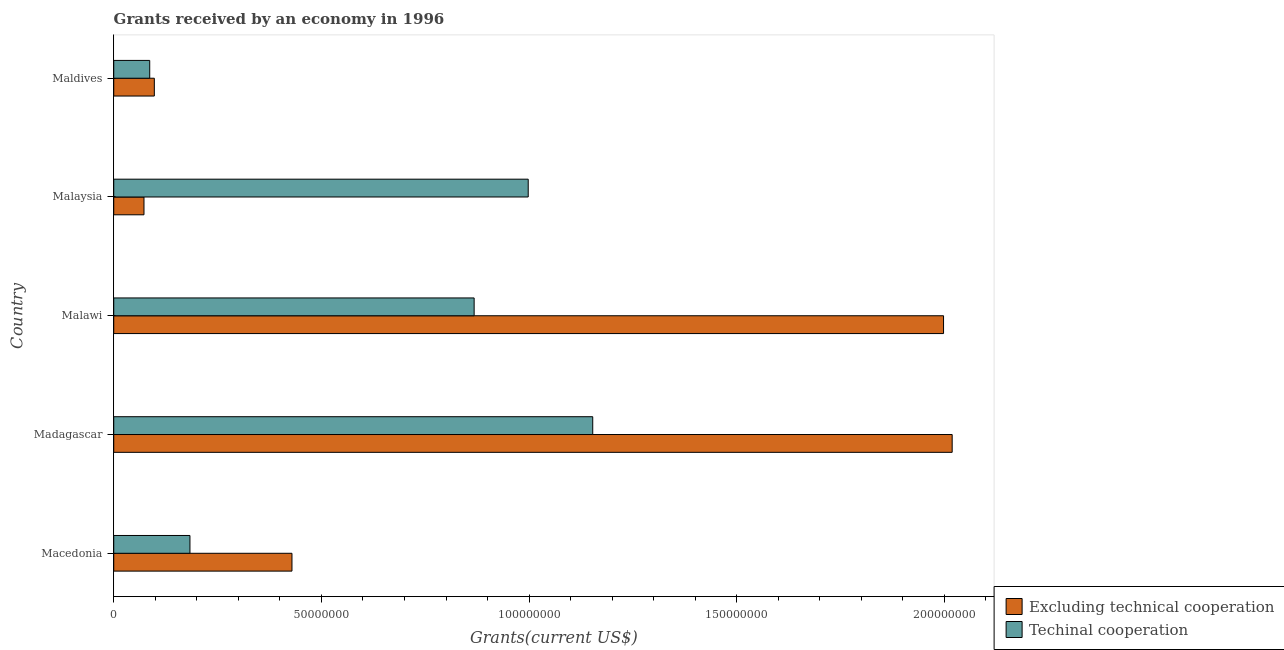How many different coloured bars are there?
Keep it short and to the point. 2. How many groups of bars are there?
Provide a succinct answer. 5. Are the number of bars per tick equal to the number of legend labels?
Ensure brevity in your answer.  Yes. Are the number of bars on each tick of the Y-axis equal?
Provide a succinct answer. Yes. How many bars are there on the 4th tick from the top?
Ensure brevity in your answer.  2. How many bars are there on the 5th tick from the bottom?
Keep it short and to the point. 2. What is the label of the 5th group of bars from the top?
Ensure brevity in your answer.  Macedonia. In how many cases, is the number of bars for a given country not equal to the number of legend labels?
Provide a short and direct response. 0. What is the amount of grants received(including technical cooperation) in Madagascar?
Your answer should be compact. 1.15e+08. Across all countries, what is the maximum amount of grants received(excluding technical cooperation)?
Offer a terse response. 2.02e+08. Across all countries, what is the minimum amount of grants received(including technical cooperation)?
Keep it short and to the point. 8.66e+06. In which country was the amount of grants received(including technical cooperation) maximum?
Offer a very short reply. Madagascar. In which country was the amount of grants received(including technical cooperation) minimum?
Offer a terse response. Maldives. What is the total amount of grants received(including technical cooperation) in the graph?
Keep it short and to the point. 3.29e+08. What is the difference between the amount of grants received(excluding technical cooperation) in Malawi and that in Malaysia?
Your response must be concise. 1.92e+08. What is the difference between the amount of grants received(excluding technical cooperation) in Malaysia and the amount of grants received(including technical cooperation) in Madagascar?
Offer a very short reply. -1.08e+08. What is the average amount of grants received(including technical cooperation) per country?
Your answer should be very brief. 6.58e+07. What is the difference between the amount of grants received(excluding technical cooperation) and amount of grants received(including technical cooperation) in Madagascar?
Make the answer very short. 8.65e+07. What is the ratio of the amount of grants received(excluding technical cooperation) in Madagascar to that in Maldives?
Offer a terse response. 20.66. Is the amount of grants received(including technical cooperation) in Macedonia less than that in Malawi?
Keep it short and to the point. Yes. What is the difference between the highest and the second highest amount of grants received(including technical cooperation)?
Your answer should be compact. 1.55e+07. What is the difference between the highest and the lowest amount of grants received(excluding technical cooperation)?
Offer a terse response. 1.95e+08. What does the 2nd bar from the top in Malaysia represents?
Your response must be concise. Excluding technical cooperation. What does the 1st bar from the bottom in Macedonia represents?
Your answer should be compact. Excluding technical cooperation. How many bars are there?
Offer a terse response. 10. Are all the bars in the graph horizontal?
Offer a very short reply. Yes. What is the difference between two consecutive major ticks on the X-axis?
Offer a terse response. 5.00e+07. Does the graph contain grids?
Give a very brief answer. No. How are the legend labels stacked?
Keep it short and to the point. Vertical. What is the title of the graph?
Ensure brevity in your answer.  Grants received by an economy in 1996. What is the label or title of the X-axis?
Offer a very short reply. Grants(current US$). What is the label or title of the Y-axis?
Ensure brevity in your answer.  Country. What is the Grants(current US$) of Excluding technical cooperation in Macedonia?
Offer a terse response. 4.29e+07. What is the Grants(current US$) of Techinal cooperation in Macedonia?
Your response must be concise. 1.84e+07. What is the Grants(current US$) of Excluding technical cooperation in Madagascar?
Keep it short and to the point. 2.02e+08. What is the Grants(current US$) of Techinal cooperation in Madagascar?
Your answer should be very brief. 1.15e+08. What is the Grants(current US$) of Excluding technical cooperation in Malawi?
Make the answer very short. 2.00e+08. What is the Grants(current US$) in Techinal cooperation in Malawi?
Provide a succinct answer. 8.68e+07. What is the Grants(current US$) in Excluding technical cooperation in Malaysia?
Keep it short and to the point. 7.28e+06. What is the Grants(current US$) in Techinal cooperation in Malaysia?
Offer a very short reply. 9.98e+07. What is the Grants(current US$) of Excluding technical cooperation in Maldives?
Make the answer very short. 9.77e+06. What is the Grants(current US$) of Techinal cooperation in Maldives?
Your answer should be very brief. 8.66e+06. Across all countries, what is the maximum Grants(current US$) in Excluding technical cooperation?
Ensure brevity in your answer.  2.02e+08. Across all countries, what is the maximum Grants(current US$) in Techinal cooperation?
Provide a succinct answer. 1.15e+08. Across all countries, what is the minimum Grants(current US$) in Excluding technical cooperation?
Offer a terse response. 7.28e+06. Across all countries, what is the minimum Grants(current US$) in Techinal cooperation?
Make the answer very short. 8.66e+06. What is the total Grants(current US$) of Excluding technical cooperation in the graph?
Your answer should be compact. 4.62e+08. What is the total Grants(current US$) of Techinal cooperation in the graph?
Your answer should be very brief. 3.29e+08. What is the difference between the Grants(current US$) in Excluding technical cooperation in Macedonia and that in Madagascar?
Give a very brief answer. -1.59e+08. What is the difference between the Grants(current US$) of Techinal cooperation in Macedonia and that in Madagascar?
Your answer should be very brief. -9.70e+07. What is the difference between the Grants(current US$) in Excluding technical cooperation in Macedonia and that in Malawi?
Offer a terse response. -1.57e+08. What is the difference between the Grants(current US$) in Techinal cooperation in Macedonia and that in Malawi?
Offer a terse response. -6.84e+07. What is the difference between the Grants(current US$) in Excluding technical cooperation in Macedonia and that in Malaysia?
Offer a terse response. 3.56e+07. What is the difference between the Grants(current US$) of Techinal cooperation in Macedonia and that in Malaysia?
Offer a terse response. -8.14e+07. What is the difference between the Grants(current US$) in Excluding technical cooperation in Macedonia and that in Maldives?
Give a very brief answer. 3.31e+07. What is the difference between the Grants(current US$) of Techinal cooperation in Macedonia and that in Maldives?
Make the answer very short. 9.69e+06. What is the difference between the Grants(current US$) in Excluding technical cooperation in Madagascar and that in Malawi?
Make the answer very short. 2.08e+06. What is the difference between the Grants(current US$) of Techinal cooperation in Madagascar and that in Malawi?
Offer a very short reply. 2.86e+07. What is the difference between the Grants(current US$) in Excluding technical cooperation in Madagascar and that in Malaysia?
Offer a very short reply. 1.95e+08. What is the difference between the Grants(current US$) in Techinal cooperation in Madagascar and that in Malaysia?
Your response must be concise. 1.55e+07. What is the difference between the Grants(current US$) in Excluding technical cooperation in Madagascar and that in Maldives?
Ensure brevity in your answer.  1.92e+08. What is the difference between the Grants(current US$) of Techinal cooperation in Madagascar and that in Maldives?
Your answer should be very brief. 1.07e+08. What is the difference between the Grants(current US$) in Excluding technical cooperation in Malawi and that in Malaysia?
Keep it short and to the point. 1.92e+08. What is the difference between the Grants(current US$) in Techinal cooperation in Malawi and that in Malaysia?
Offer a terse response. -1.30e+07. What is the difference between the Grants(current US$) in Excluding technical cooperation in Malawi and that in Maldives?
Offer a terse response. 1.90e+08. What is the difference between the Grants(current US$) of Techinal cooperation in Malawi and that in Maldives?
Provide a succinct answer. 7.81e+07. What is the difference between the Grants(current US$) of Excluding technical cooperation in Malaysia and that in Maldives?
Keep it short and to the point. -2.49e+06. What is the difference between the Grants(current US$) in Techinal cooperation in Malaysia and that in Maldives?
Give a very brief answer. 9.11e+07. What is the difference between the Grants(current US$) in Excluding technical cooperation in Macedonia and the Grants(current US$) in Techinal cooperation in Madagascar?
Your response must be concise. -7.24e+07. What is the difference between the Grants(current US$) in Excluding technical cooperation in Macedonia and the Grants(current US$) in Techinal cooperation in Malawi?
Your answer should be very brief. -4.39e+07. What is the difference between the Grants(current US$) of Excluding technical cooperation in Macedonia and the Grants(current US$) of Techinal cooperation in Malaysia?
Make the answer very short. -5.69e+07. What is the difference between the Grants(current US$) in Excluding technical cooperation in Macedonia and the Grants(current US$) in Techinal cooperation in Maldives?
Give a very brief answer. 3.42e+07. What is the difference between the Grants(current US$) of Excluding technical cooperation in Madagascar and the Grants(current US$) of Techinal cooperation in Malawi?
Provide a succinct answer. 1.15e+08. What is the difference between the Grants(current US$) of Excluding technical cooperation in Madagascar and the Grants(current US$) of Techinal cooperation in Malaysia?
Make the answer very short. 1.02e+08. What is the difference between the Grants(current US$) of Excluding technical cooperation in Madagascar and the Grants(current US$) of Techinal cooperation in Maldives?
Your answer should be compact. 1.93e+08. What is the difference between the Grants(current US$) in Excluding technical cooperation in Malawi and the Grants(current US$) in Techinal cooperation in Malaysia?
Offer a terse response. 1.00e+08. What is the difference between the Grants(current US$) of Excluding technical cooperation in Malawi and the Grants(current US$) of Techinal cooperation in Maldives?
Offer a terse response. 1.91e+08. What is the difference between the Grants(current US$) in Excluding technical cooperation in Malaysia and the Grants(current US$) in Techinal cooperation in Maldives?
Offer a very short reply. -1.38e+06. What is the average Grants(current US$) in Excluding technical cooperation per country?
Provide a succinct answer. 9.23e+07. What is the average Grants(current US$) in Techinal cooperation per country?
Make the answer very short. 6.58e+07. What is the difference between the Grants(current US$) in Excluding technical cooperation and Grants(current US$) in Techinal cooperation in Macedonia?
Ensure brevity in your answer.  2.46e+07. What is the difference between the Grants(current US$) of Excluding technical cooperation and Grants(current US$) of Techinal cooperation in Madagascar?
Your response must be concise. 8.65e+07. What is the difference between the Grants(current US$) of Excluding technical cooperation and Grants(current US$) of Techinal cooperation in Malawi?
Your answer should be very brief. 1.13e+08. What is the difference between the Grants(current US$) in Excluding technical cooperation and Grants(current US$) in Techinal cooperation in Malaysia?
Ensure brevity in your answer.  -9.25e+07. What is the difference between the Grants(current US$) in Excluding technical cooperation and Grants(current US$) in Techinal cooperation in Maldives?
Give a very brief answer. 1.11e+06. What is the ratio of the Grants(current US$) of Excluding technical cooperation in Macedonia to that in Madagascar?
Give a very brief answer. 0.21. What is the ratio of the Grants(current US$) of Techinal cooperation in Macedonia to that in Madagascar?
Provide a succinct answer. 0.16. What is the ratio of the Grants(current US$) of Excluding technical cooperation in Macedonia to that in Malawi?
Your response must be concise. 0.21. What is the ratio of the Grants(current US$) in Techinal cooperation in Macedonia to that in Malawi?
Your answer should be compact. 0.21. What is the ratio of the Grants(current US$) in Excluding technical cooperation in Macedonia to that in Malaysia?
Provide a succinct answer. 5.89. What is the ratio of the Grants(current US$) in Techinal cooperation in Macedonia to that in Malaysia?
Your answer should be compact. 0.18. What is the ratio of the Grants(current US$) in Excluding technical cooperation in Macedonia to that in Maldives?
Make the answer very short. 4.39. What is the ratio of the Grants(current US$) of Techinal cooperation in Macedonia to that in Maldives?
Give a very brief answer. 2.12. What is the ratio of the Grants(current US$) in Excluding technical cooperation in Madagascar to that in Malawi?
Offer a terse response. 1.01. What is the ratio of the Grants(current US$) in Techinal cooperation in Madagascar to that in Malawi?
Your answer should be very brief. 1.33. What is the ratio of the Grants(current US$) in Excluding technical cooperation in Madagascar to that in Malaysia?
Make the answer very short. 27.73. What is the ratio of the Grants(current US$) of Techinal cooperation in Madagascar to that in Malaysia?
Provide a succinct answer. 1.16. What is the ratio of the Grants(current US$) in Excluding technical cooperation in Madagascar to that in Maldives?
Keep it short and to the point. 20.66. What is the ratio of the Grants(current US$) of Techinal cooperation in Madagascar to that in Maldives?
Your answer should be very brief. 13.32. What is the ratio of the Grants(current US$) in Excluding technical cooperation in Malawi to that in Malaysia?
Your response must be concise. 27.44. What is the ratio of the Grants(current US$) of Techinal cooperation in Malawi to that in Malaysia?
Offer a very short reply. 0.87. What is the ratio of the Grants(current US$) of Excluding technical cooperation in Malawi to that in Maldives?
Keep it short and to the point. 20.45. What is the ratio of the Grants(current US$) of Techinal cooperation in Malawi to that in Maldives?
Offer a terse response. 10.02. What is the ratio of the Grants(current US$) of Excluding technical cooperation in Malaysia to that in Maldives?
Your answer should be very brief. 0.75. What is the ratio of the Grants(current US$) of Techinal cooperation in Malaysia to that in Maldives?
Ensure brevity in your answer.  11.52. What is the difference between the highest and the second highest Grants(current US$) of Excluding technical cooperation?
Your response must be concise. 2.08e+06. What is the difference between the highest and the second highest Grants(current US$) in Techinal cooperation?
Make the answer very short. 1.55e+07. What is the difference between the highest and the lowest Grants(current US$) in Excluding technical cooperation?
Give a very brief answer. 1.95e+08. What is the difference between the highest and the lowest Grants(current US$) in Techinal cooperation?
Keep it short and to the point. 1.07e+08. 